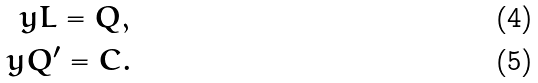Convert formula to latex. <formula><loc_0><loc_0><loc_500><loc_500>y L = Q , \\ y Q ^ { \prime } = C .</formula> 